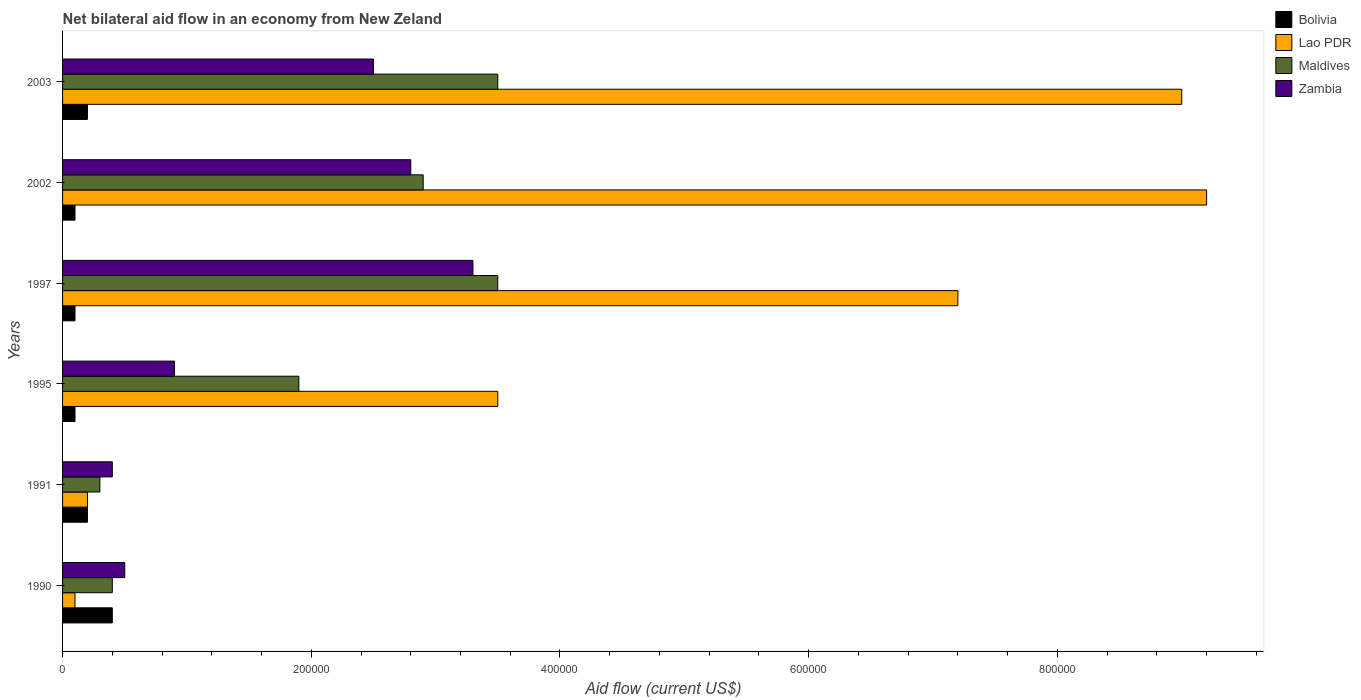How many different coloured bars are there?
Provide a succinct answer. 4. How many groups of bars are there?
Offer a terse response. 6. Are the number of bars per tick equal to the number of legend labels?
Offer a terse response. Yes. Are the number of bars on each tick of the Y-axis equal?
Your answer should be very brief. Yes. How many bars are there on the 3rd tick from the top?
Your response must be concise. 4. What is the label of the 4th group of bars from the top?
Offer a terse response. 1995. What is the net bilateral aid flow in Lao PDR in 1997?
Your answer should be compact. 7.20e+05. Across all years, what is the minimum net bilateral aid flow in Maldives?
Offer a very short reply. 3.00e+04. In which year was the net bilateral aid flow in Zambia maximum?
Your answer should be compact. 1997. In which year was the net bilateral aid flow in Zambia minimum?
Your answer should be very brief. 1991. What is the total net bilateral aid flow in Maldives in the graph?
Offer a very short reply. 1.25e+06. What is the difference between the net bilateral aid flow in Bolivia in 1991 and the net bilateral aid flow in Maldives in 1997?
Your response must be concise. -3.30e+05. What is the average net bilateral aid flow in Maldives per year?
Provide a short and direct response. 2.08e+05. In how many years, is the net bilateral aid flow in Bolivia greater than 600000 US$?
Give a very brief answer. 0. What is the ratio of the net bilateral aid flow in Lao PDR in 1991 to that in 1995?
Provide a succinct answer. 0.06. Is the difference between the net bilateral aid flow in Maldives in 2002 and 2003 greater than the difference between the net bilateral aid flow in Zambia in 2002 and 2003?
Offer a very short reply. No. What is the difference between the highest and the second highest net bilateral aid flow in Lao PDR?
Give a very brief answer. 2.00e+04. What is the difference between the highest and the lowest net bilateral aid flow in Maldives?
Provide a succinct answer. 3.20e+05. Is it the case that in every year, the sum of the net bilateral aid flow in Lao PDR and net bilateral aid flow in Maldives is greater than the sum of net bilateral aid flow in Zambia and net bilateral aid flow in Bolivia?
Your response must be concise. No. What does the 4th bar from the top in 1995 represents?
Your answer should be very brief. Bolivia. What does the 4th bar from the bottom in 1997 represents?
Offer a terse response. Zambia. Is it the case that in every year, the sum of the net bilateral aid flow in Bolivia and net bilateral aid flow in Zambia is greater than the net bilateral aid flow in Lao PDR?
Offer a terse response. No. How many bars are there?
Your answer should be very brief. 24. How many years are there in the graph?
Provide a short and direct response. 6. What is the difference between two consecutive major ticks on the X-axis?
Make the answer very short. 2.00e+05. Are the values on the major ticks of X-axis written in scientific E-notation?
Provide a succinct answer. No. Does the graph contain grids?
Your response must be concise. No. Where does the legend appear in the graph?
Your answer should be compact. Top right. How are the legend labels stacked?
Your answer should be compact. Vertical. What is the title of the graph?
Your response must be concise. Net bilateral aid flow in an economy from New Zeland. Does "Channel Islands" appear as one of the legend labels in the graph?
Your answer should be compact. No. What is the Aid flow (current US$) in Lao PDR in 1990?
Offer a terse response. 10000. What is the Aid flow (current US$) of Lao PDR in 1991?
Make the answer very short. 2.00e+04. What is the Aid flow (current US$) in Zambia in 1991?
Ensure brevity in your answer.  4.00e+04. What is the Aid flow (current US$) of Bolivia in 1995?
Your answer should be compact. 10000. What is the Aid flow (current US$) of Lao PDR in 1997?
Ensure brevity in your answer.  7.20e+05. What is the Aid flow (current US$) of Bolivia in 2002?
Make the answer very short. 10000. What is the Aid flow (current US$) in Lao PDR in 2002?
Your answer should be very brief. 9.20e+05. What is the Aid flow (current US$) of Maldives in 2002?
Give a very brief answer. 2.90e+05. What is the Aid flow (current US$) in Zambia in 2003?
Offer a very short reply. 2.50e+05. Across all years, what is the maximum Aid flow (current US$) of Bolivia?
Ensure brevity in your answer.  4.00e+04. Across all years, what is the maximum Aid flow (current US$) of Lao PDR?
Your answer should be very brief. 9.20e+05. Across all years, what is the maximum Aid flow (current US$) in Maldives?
Provide a succinct answer. 3.50e+05. Across all years, what is the maximum Aid flow (current US$) in Zambia?
Your response must be concise. 3.30e+05. Across all years, what is the minimum Aid flow (current US$) of Bolivia?
Make the answer very short. 10000. Across all years, what is the minimum Aid flow (current US$) in Lao PDR?
Keep it short and to the point. 10000. Across all years, what is the minimum Aid flow (current US$) of Maldives?
Ensure brevity in your answer.  3.00e+04. What is the total Aid flow (current US$) in Lao PDR in the graph?
Keep it short and to the point. 2.92e+06. What is the total Aid flow (current US$) of Maldives in the graph?
Offer a very short reply. 1.25e+06. What is the total Aid flow (current US$) in Zambia in the graph?
Keep it short and to the point. 1.04e+06. What is the difference between the Aid flow (current US$) of Bolivia in 1990 and that in 1991?
Keep it short and to the point. 2.00e+04. What is the difference between the Aid flow (current US$) of Maldives in 1990 and that in 1991?
Ensure brevity in your answer.  10000. What is the difference between the Aid flow (current US$) of Bolivia in 1990 and that in 1995?
Make the answer very short. 3.00e+04. What is the difference between the Aid flow (current US$) in Lao PDR in 1990 and that in 1995?
Provide a succinct answer. -3.40e+05. What is the difference between the Aid flow (current US$) of Lao PDR in 1990 and that in 1997?
Your answer should be compact. -7.10e+05. What is the difference between the Aid flow (current US$) of Maldives in 1990 and that in 1997?
Your answer should be compact. -3.10e+05. What is the difference between the Aid flow (current US$) in Zambia in 1990 and that in 1997?
Provide a succinct answer. -2.80e+05. What is the difference between the Aid flow (current US$) of Bolivia in 1990 and that in 2002?
Provide a succinct answer. 3.00e+04. What is the difference between the Aid flow (current US$) in Lao PDR in 1990 and that in 2002?
Keep it short and to the point. -9.10e+05. What is the difference between the Aid flow (current US$) in Lao PDR in 1990 and that in 2003?
Keep it short and to the point. -8.90e+05. What is the difference between the Aid flow (current US$) in Maldives in 1990 and that in 2003?
Offer a very short reply. -3.10e+05. What is the difference between the Aid flow (current US$) in Zambia in 1990 and that in 2003?
Offer a very short reply. -2.00e+05. What is the difference between the Aid flow (current US$) in Bolivia in 1991 and that in 1995?
Offer a terse response. 10000. What is the difference between the Aid flow (current US$) of Lao PDR in 1991 and that in 1995?
Provide a succinct answer. -3.30e+05. What is the difference between the Aid flow (current US$) of Maldives in 1991 and that in 1995?
Your answer should be very brief. -1.60e+05. What is the difference between the Aid flow (current US$) of Lao PDR in 1991 and that in 1997?
Give a very brief answer. -7.00e+05. What is the difference between the Aid flow (current US$) of Maldives in 1991 and that in 1997?
Make the answer very short. -3.20e+05. What is the difference between the Aid flow (current US$) of Bolivia in 1991 and that in 2002?
Ensure brevity in your answer.  10000. What is the difference between the Aid flow (current US$) of Lao PDR in 1991 and that in 2002?
Your response must be concise. -9.00e+05. What is the difference between the Aid flow (current US$) in Maldives in 1991 and that in 2002?
Keep it short and to the point. -2.60e+05. What is the difference between the Aid flow (current US$) of Bolivia in 1991 and that in 2003?
Your answer should be very brief. 0. What is the difference between the Aid flow (current US$) in Lao PDR in 1991 and that in 2003?
Keep it short and to the point. -8.80e+05. What is the difference between the Aid flow (current US$) of Maldives in 1991 and that in 2003?
Offer a very short reply. -3.20e+05. What is the difference between the Aid flow (current US$) of Bolivia in 1995 and that in 1997?
Make the answer very short. 0. What is the difference between the Aid flow (current US$) in Lao PDR in 1995 and that in 1997?
Offer a very short reply. -3.70e+05. What is the difference between the Aid flow (current US$) in Zambia in 1995 and that in 1997?
Your answer should be very brief. -2.40e+05. What is the difference between the Aid flow (current US$) of Lao PDR in 1995 and that in 2002?
Your response must be concise. -5.70e+05. What is the difference between the Aid flow (current US$) in Maldives in 1995 and that in 2002?
Provide a succinct answer. -1.00e+05. What is the difference between the Aid flow (current US$) in Bolivia in 1995 and that in 2003?
Offer a terse response. -10000. What is the difference between the Aid flow (current US$) of Lao PDR in 1995 and that in 2003?
Give a very brief answer. -5.50e+05. What is the difference between the Aid flow (current US$) in Maldives in 1995 and that in 2003?
Keep it short and to the point. -1.60e+05. What is the difference between the Aid flow (current US$) of Bolivia in 1997 and that in 2002?
Your answer should be very brief. 0. What is the difference between the Aid flow (current US$) in Lao PDR in 1997 and that in 2002?
Your answer should be very brief. -2.00e+05. What is the difference between the Aid flow (current US$) of Maldives in 1997 and that in 2002?
Keep it short and to the point. 6.00e+04. What is the difference between the Aid flow (current US$) of Lao PDR in 1997 and that in 2003?
Your response must be concise. -1.80e+05. What is the difference between the Aid flow (current US$) in Zambia in 1997 and that in 2003?
Make the answer very short. 8.00e+04. What is the difference between the Aid flow (current US$) in Lao PDR in 2002 and that in 2003?
Keep it short and to the point. 2.00e+04. What is the difference between the Aid flow (current US$) in Maldives in 2002 and that in 2003?
Make the answer very short. -6.00e+04. What is the difference between the Aid flow (current US$) in Zambia in 2002 and that in 2003?
Give a very brief answer. 3.00e+04. What is the difference between the Aid flow (current US$) of Maldives in 1990 and the Aid flow (current US$) of Zambia in 1991?
Your answer should be compact. 0. What is the difference between the Aid flow (current US$) of Bolivia in 1990 and the Aid flow (current US$) of Lao PDR in 1995?
Make the answer very short. -3.10e+05. What is the difference between the Aid flow (current US$) in Bolivia in 1990 and the Aid flow (current US$) in Maldives in 1995?
Ensure brevity in your answer.  -1.50e+05. What is the difference between the Aid flow (current US$) of Maldives in 1990 and the Aid flow (current US$) of Zambia in 1995?
Your answer should be compact. -5.00e+04. What is the difference between the Aid flow (current US$) in Bolivia in 1990 and the Aid flow (current US$) in Lao PDR in 1997?
Provide a succinct answer. -6.80e+05. What is the difference between the Aid flow (current US$) in Bolivia in 1990 and the Aid flow (current US$) in Maldives in 1997?
Your answer should be compact. -3.10e+05. What is the difference between the Aid flow (current US$) in Lao PDR in 1990 and the Aid flow (current US$) in Maldives in 1997?
Keep it short and to the point. -3.40e+05. What is the difference between the Aid flow (current US$) in Lao PDR in 1990 and the Aid flow (current US$) in Zambia in 1997?
Give a very brief answer. -3.20e+05. What is the difference between the Aid flow (current US$) in Maldives in 1990 and the Aid flow (current US$) in Zambia in 1997?
Provide a succinct answer. -2.90e+05. What is the difference between the Aid flow (current US$) in Bolivia in 1990 and the Aid flow (current US$) in Lao PDR in 2002?
Provide a short and direct response. -8.80e+05. What is the difference between the Aid flow (current US$) in Lao PDR in 1990 and the Aid flow (current US$) in Maldives in 2002?
Your answer should be compact. -2.80e+05. What is the difference between the Aid flow (current US$) of Lao PDR in 1990 and the Aid flow (current US$) of Zambia in 2002?
Offer a terse response. -2.70e+05. What is the difference between the Aid flow (current US$) of Maldives in 1990 and the Aid flow (current US$) of Zambia in 2002?
Provide a succinct answer. -2.40e+05. What is the difference between the Aid flow (current US$) of Bolivia in 1990 and the Aid flow (current US$) of Lao PDR in 2003?
Keep it short and to the point. -8.60e+05. What is the difference between the Aid flow (current US$) of Bolivia in 1990 and the Aid flow (current US$) of Maldives in 2003?
Provide a short and direct response. -3.10e+05. What is the difference between the Aid flow (current US$) of Bolivia in 1990 and the Aid flow (current US$) of Zambia in 2003?
Provide a short and direct response. -2.10e+05. What is the difference between the Aid flow (current US$) of Lao PDR in 1990 and the Aid flow (current US$) of Maldives in 2003?
Make the answer very short. -3.40e+05. What is the difference between the Aid flow (current US$) of Maldives in 1990 and the Aid flow (current US$) of Zambia in 2003?
Your answer should be very brief. -2.10e+05. What is the difference between the Aid flow (current US$) in Bolivia in 1991 and the Aid flow (current US$) in Lao PDR in 1995?
Keep it short and to the point. -3.30e+05. What is the difference between the Aid flow (current US$) in Bolivia in 1991 and the Aid flow (current US$) in Zambia in 1995?
Ensure brevity in your answer.  -7.00e+04. What is the difference between the Aid flow (current US$) in Maldives in 1991 and the Aid flow (current US$) in Zambia in 1995?
Make the answer very short. -6.00e+04. What is the difference between the Aid flow (current US$) of Bolivia in 1991 and the Aid flow (current US$) of Lao PDR in 1997?
Make the answer very short. -7.00e+05. What is the difference between the Aid flow (current US$) in Bolivia in 1991 and the Aid flow (current US$) in Maldives in 1997?
Your response must be concise. -3.30e+05. What is the difference between the Aid flow (current US$) in Bolivia in 1991 and the Aid flow (current US$) in Zambia in 1997?
Offer a terse response. -3.10e+05. What is the difference between the Aid flow (current US$) in Lao PDR in 1991 and the Aid flow (current US$) in Maldives in 1997?
Your answer should be very brief. -3.30e+05. What is the difference between the Aid flow (current US$) of Lao PDR in 1991 and the Aid flow (current US$) of Zambia in 1997?
Make the answer very short. -3.10e+05. What is the difference between the Aid flow (current US$) of Maldives in 1991 and the Aid flow (current US$) of Zambia in 1997?
Ensure brevity in your answer.  -3.00e+05. What is the difference between the Aid flow (current US$) in Bolivia in 1991 and the Aid flow (current US$) in Lao PDR in 2002?
Provide a succinct answer. -9.00e+05. What is the difference between the Aid flow (current US$) in Lao PDR in 1991 and the Aid flow (current US$) in Maldives in 2002?
Offer a very short reply. -2.70e+05. What is the difference between the Aid flow (current US$) of Lao PDR in 1991 and the Aid flow (current US$) of Zambia in 2002?
Your answer should be very brief. -2.60e+05. What is the difference between the Aid flow (current US$) in Maldives in 1991 and the Aid flow (current US$) in Zambia in 2002?
Provide a short and direct response. -2.50e+05. What is the difference between the Aid flow (current US$) in Bolivia in 1991 and the Aid flow (current US$) in Lao PDR in 2003?
Keep it short and to the point. -8.80e+05. What is the difference between the Aid flow (current US$) of Bolivia in 1991 and the Aid flow (current US$) of Maldives in 2003?
Provide a short and direct response. -3.30e+05. What is the difference between the Aid flow (current US$) in Bolivia in 1991 and the Aid flow (current US$) in Zambia in 2003?
Ensure brevity in your answer.  -2.30e+05. What is the difference between the Aid flow (current US$) in Lao PDR in 1991 and the Aid flow (current US$) in Maldives in 2003?
Ensure brevity in your answer.  -3.30e+05. What is the difference between the Aid flow (current US$) of Lao PDR in 1991 and the Aid flow (current US$) of Zambia in 2003?
Your response must be concise. -2.30e+05. What is the difference between the Aid flow (current US$) in Maldives in 1991 and the Aid flow (current US$) in Zambia in 2003?
Ensure brevity in your answer.  -2.20e+05. What is the difference between the Aid flow (current US$) of Bolivia in 1995 and the Aid flow (current US$) of Lao PDR in 1997?
Your response must be concise. -7.10e+05. What is the difference between the Aid flow (current US$) in Bolivia in 1995 and the Aid flow (current US$) in Zambia in 1997?
Give a very brief answer. -3.20e+05. What is the difference between the Aid flow (current US$) of Lao PDR in 1995 and the Aid flow (current US$) of Maldives in 1997?
Provide a succinct answer. 0. What is the difference between the Aid flow (current US$) of Maldives in 1995 and the Aid flow (current US$) of Zambia in 1997?
Offer a very short reply. -1.40e+05. What is the difference between the Aid flow (current US$) in Bolivia in 1995 and the Aid flow (current US$) in Lao PDR in 2002?
Make the answer very short. -9.10e+05. What is the difference between the Aid flow (current US$) of Bolivia in 1995 and the Aid flow (current US$) of Maldives in 2002?
Ensure brevity in your answer.  -2.80e+05. What is the difference between the Aid flow (current US$) in Bolivia in 1995 and the Aid flow (current US$) in Zambia in 2002?
Give a very brief answer. -2.70e+05. What is the difference between the Aid flow (current US$) in Lao PDR in 1995 and the Aid flow (current US$) in Maldives in 2002?
Keep it short and to the point. 6.00e+04. What is the difference between the Aid flow (current US$) in Bolivia in 1995 and the Aid flow (current US$) in Lao PDR in 2003?
Ensure brevity in your answer.  -8.90e+05. What is the difference between the Aid flow (current US$) of Bolivia in 1995 and the Aid flow (current US$) of Maldives in 2003?
Your answer should be very brief. -3.40e+05. What is the difference between the Aid flow (current US$) of Bolivia in 1995 and the Aid flow (current US$) of Zambia in 2003?
Your answer should be very brief. -2.40e+05. What is the difference between the Aid flow (current US$) in Bolivia in 1997 and the Aid flow (current US$) in Lao PDR in 2002?
Give a very brief answer. -9.10e+05. What is the difference between the Aid flow (current US$) in Bolivia in 1997 and the Aid flow (current US$) in Maldives in 2002?
Your response must be concise. -2.80e+05. What is the difference between the Aid flow (current US$) of Bolivia in 1997 and the Aid flow (current US$) of Zambia in 2002?
Provide a succinct answer. -2.70e+05. What is the difference between the Aid flow (current US$) of Maldives in 1997 and the Aid flow (current US$) of Zambia in 2002?
Ensure brevity in your answer.  7.00e+04. What is the difference between the Aid flow (current US$) in Bolivia in 1997 and the Aid flow (current US$) in Lao PDR in 2003?
Make the answer very short. -8.90e+05. What is the difference between the Aid flow (current US$) in Bolivia in 1997 and the Aid flow (current US$) in Zambia in 2003?
Provide a short and direct response. -2.40e+05. What is the difference between the Aid flow (current US$) in Lao PDR in 1997 and the Aid flow (current US$) in Maldives in 2003?
Offer a terse response. 3.70e+05. What is the difference between the Aid flow (current US$) of Maldives in 1997 and the Aid flow (current US$) of Zambia in 2003?
Offer a very short reply. 1.00e+05. What is the difference between the Aid flow (current US$) in Bolivia in 2002 and the Aid flow (current US$) in Lao PDR in 2003?
Give a very brief answer. -8.90e+05. What is the difference between the Aid flow (current US$) in Lao PDR in 2002 and the Aid flow (current US$) in Maldives in 2003?
Your answer should be very brief. 5.70e+05. What is the difference between the Aid flow (current US$) of Lao PDR in 2002 and the Aid flow (current US$) of Zambia in 2003?
Ensure brevity in your answer.  6.70e+05. What is the difference between the Aid flow (current US$) of Maldives in 2002 and the Aid flow (current US$) of Zambia in 2003?
Ensure brevity in your answer.  4.00e+04. What is the average Aid flow (current US$) of Bolivia per year?
Your answer should be compact. 1.83e+04. What is the average Aid flow (current US$) in Lao PDR per year?
Provide a succinct answer. 4.87e+05. What is the average Aid flow (current US$) of Maldives per year?
Provide a short and direct response. 2.08e+05. What is the average Aid flow (current US$) of Zambia per year?
Ensure brevity in your answer.  1.73e+05. In the year 1990, what is the difference between the Aid flow (current US$) of Bolivia and Aid flow (current US$) of Lao PDR?
Make the answer very short. 3.00e+04. In the year 1990, what is the difference between the Aid flow (current US$) in Lao PDR and Aid flow (current US$) in Maldives?
Offer a terse response. -3.00e+04. In the year 1990, what is the difference between the Aid flow (current US$) in Maldives and Aid flow (current US$) in Zambia?
Your answer should be very brief. -10000. In the year 1991, what is the difference between the Aid flow (current US$) of Bolivia and Aid flow (current US$) of Lao PDR?
Make the answer very short. 0. In the year 1991, what is the difference between the Aid flow (current US$) of Lao PDR and Aid flow (current US$) of Zambia?
Provide a short and direct response. -2.00e+04. In the year 1991, what is the difference between the Aid flow (current US$) of Maldives and Aid flow (current US$) of Zambia?
Give a very brief answer. -10000. In the year 1995, what is the difference between the Aid flow (current US$) of Bolivia and Aid flow (current US$) of Lao PDR?
Ensure brevity in your answer.  -3.40e+05. In the year 1995, what is the difference between the Aid flow (current US$) of Lao PDR and Aid flow (current US$) of Maldives?
Provide a short and direct response. 1.60e+05. In the year 1997, what is the difference between the Aid flow (current US$) in Bolivia and Aid flow (current US$) in Lao PDR?
Give a very brief answer. -7.10e+05. In the year 1997, what is the difference between the Aid flow (current US$) in Bolivia and Aid flow (current US$) in Maldives?
Keep it short and to the point. -3.40e+05. In the year 1997, what is the difference between the Aid flow (current US$) in Bolivia and Aid flow (current US$) in Zambia?
Keep it short and to the point. -3.20e+05. In the year 1997, what is the difference between the Aid flow (current US$) of Lao PDR and Aid flow (current US$) of Maldives?
Ensure brevity in your answer.  3.70e+05. In the year 1997, what is the difference between the Aid flow (current US$) of Lao PDR and Aid flow (current US$) of Zambia?
Keep it short and to the point. 3.90e+05. In the year 2002, what is the difference between the Aid flow (current US$) in Bolivia and Aid flow (current US$) in Lao PDR?
Keep it short and to the point. -9.10e+05. In the year 2002, what is the difference between the Aid flow (current US$) of Bolivia and Aid flow (current US$) of Maldives?
Ensure brevity in your answer.  -2.80e+05. In the year 2002, what is the difference between the Aid flow (current US$) of Bolivia and Aid flow (current US$) of Zambia?
Offer a very short reply. -2.70e+05. In the year 2002, what is the difference between the Aid flow (current US$) of Lao PDR and Aid flow (current US$) of Maldives?
Ensure brevity in your answer.  6.30e+05. In the year 2002, what is the difference between the Aid flow (current US$) in Lao PDR and Aid flow (current US$) in Zambia?
Keep it short and to the point. 6.40e+05. In the year 2003, what is the difference between the Aid flow (current US$) of Bolivia and Aid flow (current US$) of Lao PDR?
Keep it short and to the point. -8.80e+05. In the year 2003, what is the difference between the Aid flow (current US$) of Bolivia and Aid flow (current US$) of Maldives?
Provide a short and direct response. -3.30e+05. In the year 2003, what is the difference between the Aid flow (current US$) of Lao PDR and Aid flow (current US$) of Zambia?
Provide a succinct answer. 6.50e+05. What is the ratio of the Aid flow (current US$) of Lao PDR in 1990 to that in 1991?
Offer a very short reply. 0.5. What is the ratio of the Aid flow (current US$) in Maldives in 1990 to that in 1991?
Your answer should be compact. 1.33. What is the ratio of the Aid flow (current US$) of Lao PDR in 1990 to that in 1995?
Offer a very short reply. 0.03. What is the ratio of the Aid flow (current US$) in Maldives in 1990 to that in 1995?
Your answer should be compact. 0.21. What is the ratio of the Aid flow (current US$) in Zambia in 1990 to that in 1995?
Provide a succinct answer. 0.56. What is the ratio of the Aid flow (current US$) in Bolivia in 1990 to that in 1997?
Offer a terse response. 4. What is the ratio of the Aid flow (current US$) in Lao PDR in 1990 to that in 1997?
Provide a short and direct response. 0.01. What is the ratio of the Aid flow (current US$) in Maldives in 1990 to that in 1997?
Make the answer very short. 0.11. What is the ratio of the Aid flow (current US$) of Zambia in 1990 to that in 1997?
Offer a very short reply. 0.15. What is the ratio of the Aid flow (current US$) of Lao PDR in 1990 to that in 2002?
Ensure brevity in your answer.  0.01. What is the ratio of the Aid flow (current US$) in Maldives in 1990 to that in 2002?
Your answer should be very brief. 0.14. What is the ratio of the Aid flow (current US$) in Zambia in 1990 to that in 2002?
Provide a short and direct response. 0.18. What is the ratio of the Aid flow (current US$) in Lao PDR in 1990 to that in 2003?
Provide a short and direct response. 0.01. What is the ratio of the Aid flow (current US$) of Maldives in 1990 to that in 2003?
Give a very brief answer. 0.11. What is the ratio of the Aid flow (current US$) in Zambia in 1990 to that in 2003?
Your response must be concise. 0.2. What is the ratio of the Aid flow (current US$) of Lao PDR in 1991 to that in 1995?
Ensure brevity in your answer.  0.06. What is the ratio of the Aid flow (current US$) in Maldives in 1991 to that in 1995?
Keep it short and to the point. 0.16. What is the ratio of the Aid flow (current US$) of Zambia in 1991 to that in 1995?
Your answer should be compact. 0.44. What is the ratio of the Aid flow (current US$) in Lao PDR in 1991 to that in 1997?
Provide a succinct answer. 0.03. What is the ratio of the Aid flow (current US$) of Maldives in 1991 to that in 1997?
Your response must be concise. 0.09. What is the ratio of the Aid flow (current US$) in Zambia in 1991 to that in 1997?
Keep it short and to the point. 0.12. What is the ratio of the Aid flow (current US$) in Bolivia in 1991 to that in 2002?
Offer a terse response. 2. What is the ratio of the Aid flow (current US$) in Lao PDR in 1991 to that in 2002?
Your answer should be very brief. 0.02. What is the ratio of the Aid flow (current US$) of Maldives in 1991 to that in 2002?
Ensure brevity in your answer.  0.1. What is the ratio of the Aid flow (current US$) of Zambia in 1991 to that in 2002?
Keep it short and to the point. 0.14. What is the ratio of the Aid flow (current US$) of Lao PDR in 1991 to that in 2003?
Keep it short and to the point. 0.02. What is the ratio of the Aid flow (current US$) of Maldives in 1991 to that in 2003?
Offer a very short reply. 0.09. What is the ratio of the Aid flow (current US$) of Zambia in 1991 to that in 2003?
Offer a very short reply. 0.16. What is the ratio of the Aid flow (current US$) in Lao PDR in 1995 to that in 1997?
Your answer should be compact. 0.49. What is the ratio of the Aid flow (current US$) in Maldives in 1995 to that in 1997?
Your answer should be compact. 0.54. What is the ratio of the Aid flow (current US$) of Zambia in 1995 to that in 1997?
Offer a terse response. 0.27. What is the ratio of the Aid flow (current US$) in Bolivia in 1995 to that in 2002?
Keep it short and to the point. 1. What is the ratio of the Aid flow (current US$) of Lao PDR in 1995 to that in 2002?
Make the answer very short. 0.38. What is the ratio of the Aid flow (current US$) of Maldives in 1995 to that in 2002?
Ensure brevity in your answer.  0.66. What is the ratio of the Aid flow (current US$) in Zambia in 1995 to that in 2002?
Keep it short and to the point. 0.32. What is the ratio of the Aid flow (current US$) of Bolivia in 1995 to that in 2003?
Your answer should be compact. 0.5. What is the ratio of the Aid flow (current US$) of Lao PDR in 1995 to that in 2003?
Your answer should be compact. 0.39. What is the ratio of the Aid flow (current US$) in Maldives in 1995 to that in 2003?
Make the answer very short. 0.54. What is the ratio of the Aid flow (current US$) of Zambia in 1995 to that in 2003?
Offer a terse response. 0.36. What is the ratio of the Aid flow (current US$) in Lao PDR in 1997 to that in 2002?
Offer a terse response. 0.78. What is the ratio of the Aid flow (current US$) in Maldives in 1997 to that in 2002?
Offer a terse response. 1.21. What is the ratio of the Aid flow (current US$) of Zambia in 1997 to that in 2002?
Provide a short and direct response. 1.18. What is the ratio of the Aid flow (current US$) in Bolivia in 1997 to that in 2003?
Your answer should be very brief. 0.5. What is the ratio of the Aid flow (current US$) in Maldives in 1997 to that in 2003?
Offer a terse response. 1. What is the ratio of the Aid flow (current US$) in Zambia in 1997 to that in 2003?
Your answer should be very brief. 1.32. What is the ratio of the Aid flow (current US$) in Bolivia in 2002 to that in 2003?
Give a very brief answer. 0.5. What is the ratio of the Aid flow (current US$) of Lao PDR in 2002 to that in 2003?
Offer a very short reply. 1.02. What is the ratio of the Aid flow (current US$) of Maldives in 2002 to that in 2003?
Keep it short and to the point. 0.83. What is the ratio of the Aid flow (current US$) of Zambia in 2002 to that in 2003?
Give a very brief answer. 1.12. What is the difference between the highest and the second highest Aid flow (current US$) of Bolivia?
Your response must be concise. 2.00e+04. What is the difference between the highest and the second highest Aid flow (current US$) of Lao PDR?
Your answer should be compact. 2.00e+04. What is the difference between the highest and the second highest Aid flow (current US$) of Zambia?
Offer a terse response. 5.00e+04. What is the difference between the highest and the lowest Aid flow (current US$) of Lao PDR?
Provide a short and direct response. 9.10e+05. What is the difference between the highest and the lowest Aid flow (current US$) in Maldives?
Your response must be concise. 3.20e+05. 